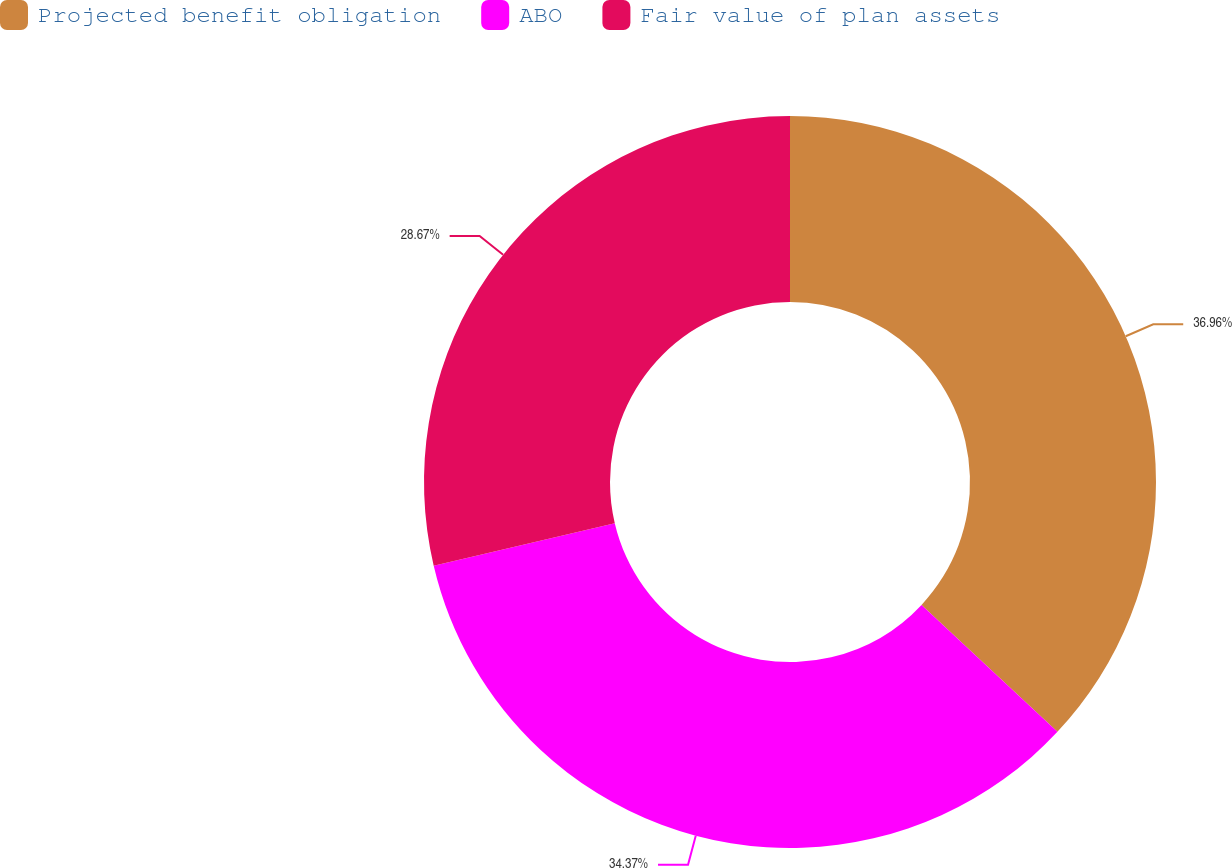<chart> <loc_0><loc_0><loc_500><loc_500><pie_chart><fcel>Projected benefit obligation<fcel>ABO<fcel>Fair value of plan assets<nl><fcel>36.96%<fcel>34.37%<fcel>28.67%<nl></chart> 